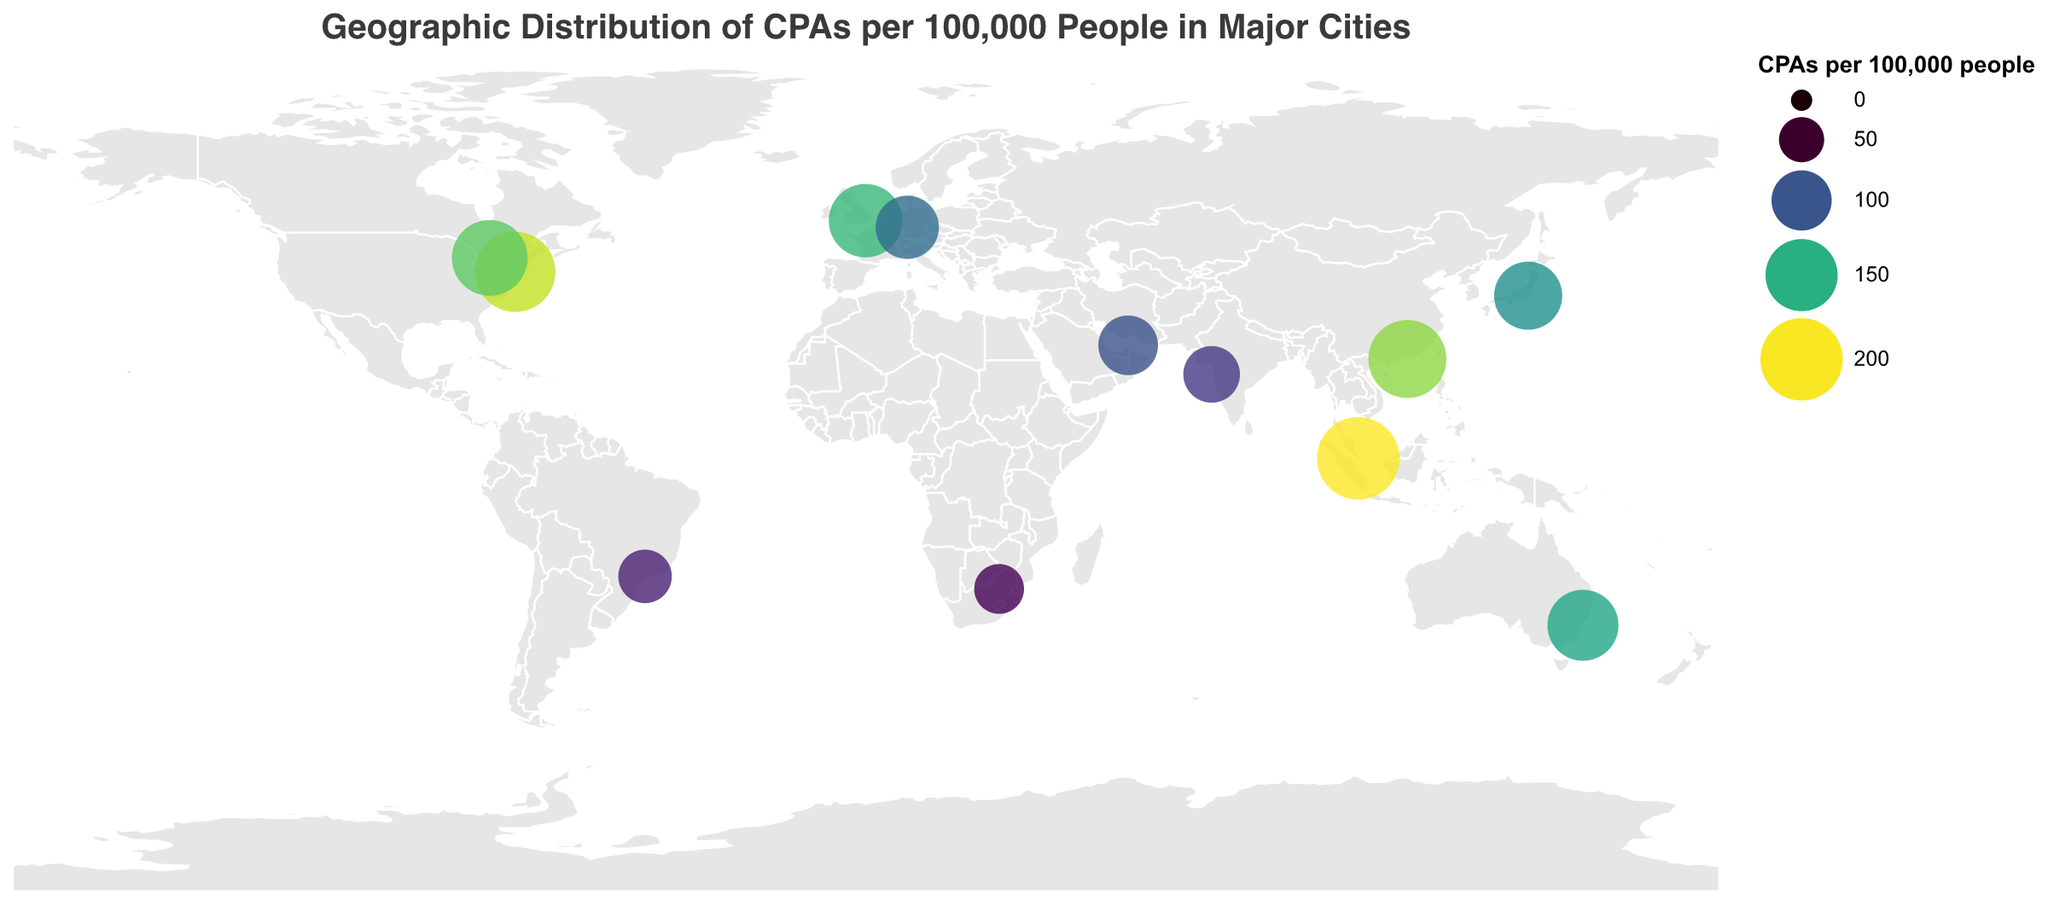What is the title of the figure? The title of the figure is prominently displayed at the top and reads "Geographic Distribution of CPAs per 100,000 People in Major Cities".
Answer: Geographic Distribution of CPAs per 100,000 People in Major Cities Which city has the highest number of CPAs per 100,000 people? By looking at the size and tooltip information of the circles, we can see that Singapore has the highest number with 201 CPAs per 100,000 people.
Answer: Singapore What is the CPAs per 100,000 people value for New York City? By referring to the tooltip for New York City, the CPAs per 100,000 people is 189.
Answer: 189 Which cities have fewer than 100 CPAs per 100,000 people? From the tooltip and circle sizes, we observe that Dubai, Mumbai, São Paulo, and Johannesburg have fewer than 100 CPAs per 100,000 people.
Answer: Dubai, Mumbai, São Paulo, Johannesburg How do the numbers of CPAs per 100,000 in Sydney and Toronto compare? Sydney has 145 CPAs per 100,000 people while Toronto has 167. Thus, Toronto has more CPAs per 100,000 people compared to Sydney.
Answer: Toronto has more What is the average number of CPAs per 100,000 people across all the cities shown? Adding up all values and dividing by the number of cities (12), we get: (189 + 156 + 132 + 145 + 167 + 201 + 178 + 112 + 98 + 87 + 76 + 64) / 12 = 137.0833.
Answer: 137.08 Which city in the USA is represented in the figure, and what data is displayed about it? The figure lists New York City in the USA with 189 CPAs per 100,000 people.
Answer: New York City, 189 CPAs per 100,000 people What patterns or trends can you see in the global distribution of CPAs per 100,000 people? Higher values are generally found in cities in developed economies such as Singapore, New York, and Hong Kong, while lower values are found in cities in developing economies like Johannesburg and São Paulo.
Answer: Developed cities tend to have more CPAs How does the number of CPAs per 100,000 in Mumbai compare to São Paulo? Mumbai has 87 CPAs per 100,000 people while São Paulo has 76, so Mumbai has more CPAs per 100,000 people.
Answer: Mumbai has more What is the range of CPAs per 100,000 people across all cities? The minimum value is 64 (Johannesburg) and the maximum value is 201 (Singapore). The range is 201 - 64 = 137.
Answer: 137 